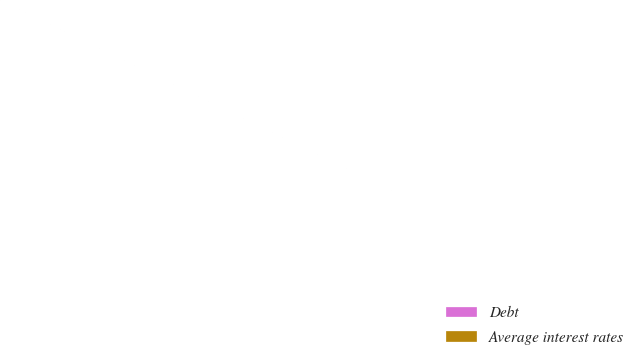Convert chart. <chart><loc_0><loc_0><loc_500><loc_500><pie_chart><fcel>Debt<fcel>Average interest rates<nl><fcel>100.0%<fcel>0.0%<nl></chart> 